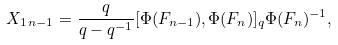Convert formula to latex. <formula><loc_0><loc_0><loc_500><loc_500>X _ { 1 \, n - 1 } = \frac { q } { q - q ^ { - 1 } } [ \Phi ( F _ { n - 1 } ) , \Phi ( F _ { n } ) ] _ { q } \Phi ( F _ { n } ) ^ { - 1 } ,</formula> 